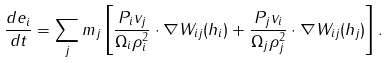Convert formula to latex. <formula><loc_0><loc_0><loc_500><loc_500>\frac { d e _ { i } } { d t } = \sum _ { j } m _ { j } \left [ \frac { P _ { i } { v } _ { j } } { \Omega _ { i } \rho _ { i } ^ { 2 } } \cdot \nabla W _ { i j } ( h _ { i } ) + \frac { P _ { j } { v } _ { i } } { \Omega _ { j } \rho _ { j } ^ { 2 } } \cdot \nabla W _ { i j } ( h _ { j } ) \right ] .</formula> 